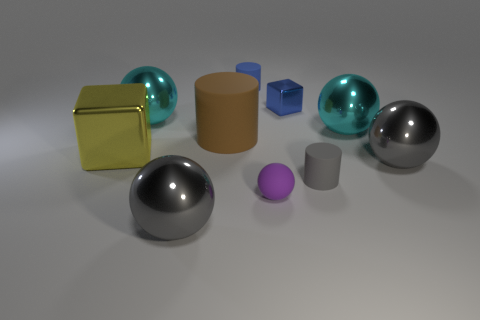There is another tiny thing that is the same color as the tiny metallic thing; what material is it?
Your answer should be very brief. Rubber. What is the size of the object that is the same color as the small cube?
Offer a very short reply. Small. Are there any other things that are made of the same material as the purple ball?
Offer a very short reply. Yes. There is a big thing that is the same material as the blue cylinder; what shape is it?
Your response must be concise. Cylinder. Is there anything else that is the same color as the rubber sphere?
Keep it short and to the point. No. What number of metallic objects are there?
Give a very brief answer. 6. What is the large gray sphere to the right of the large cyan metal sphere that is on the right side of the brown cylinder made of?
Provide a short and direct response. Metal. There is a metal cube in front of the cyan metal sphere that is on the right side of the tiny purple rubber thing on the right side of the tiny blue cylinder; what color is it?
Offer a very short reply. Yellow. Does the tiny matte sphere have the same color as the small shiny block?
Ensure brevity in your answer.  No. How many cylinders are the same size as the matte ball?
Provide a succinct answer. 2. 